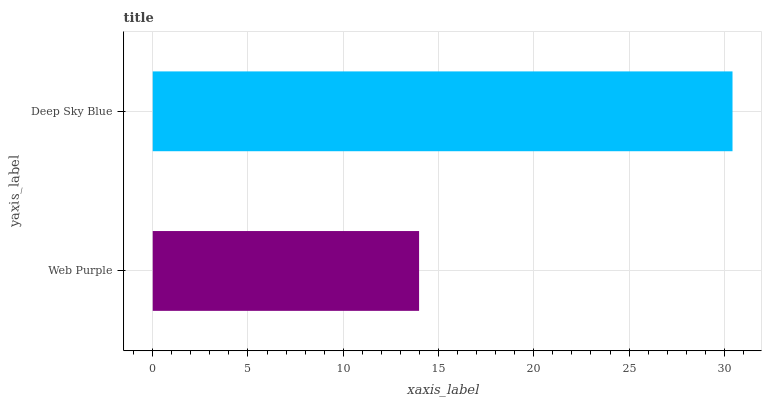Is Web Purple the minimum?
Answer yes or no. Yes. Is Deep Sky Blue the maximum?
Answer yes or no. Yes. Is Deep Sky Blue the minimum?
Answer yes or no. No. Is Deep Sky Blue greater than Web Purple?
Answer yes or no. Yes. Is Web Purple less than Deep Sky Blue?
Answer yes or no. Yes. Is Web Purple greater than Deep Sky Blue?
Answer yes or no. No. Is Deep Sky Blue less than Web Purple?
Answer yes or no. No. Is Deep Sky Blue the high median?
Answer yes or no. Yes. Is Web Purple the low median?
Answer yes or no. Yes. Is Web Purple the high median?
Answer yes or no. No. Is Deep Sky Blue the low median?
Answer yes or no. No. 